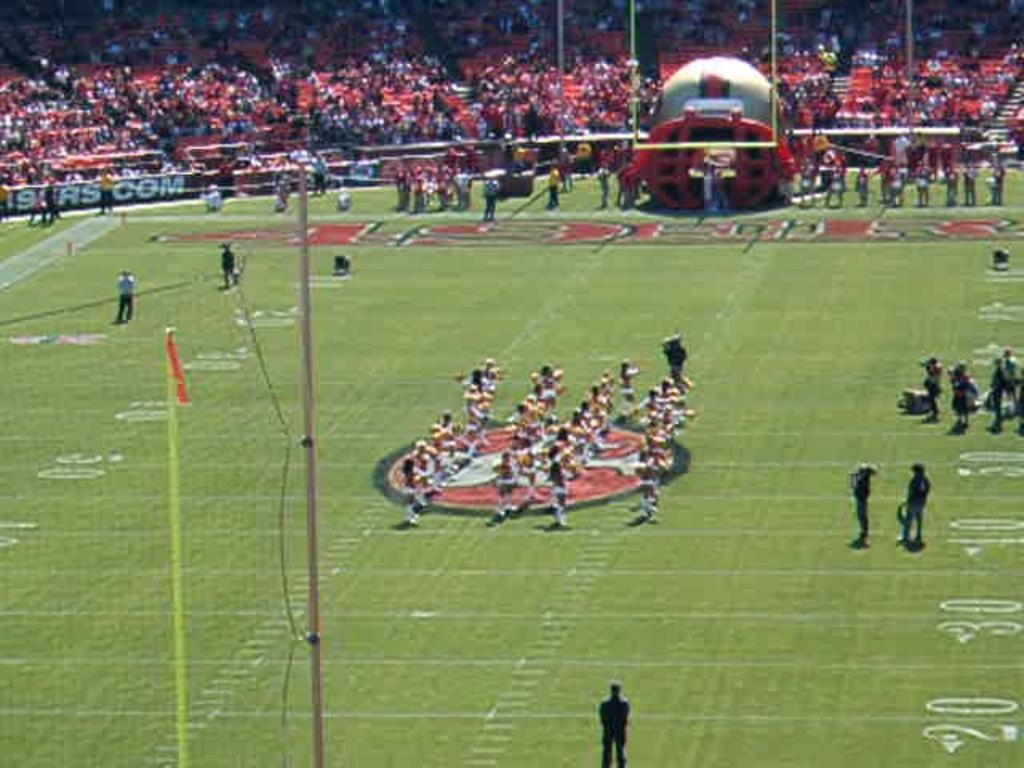Could you give a brief overview of what you see in this image? In the picture we can see a playground with green color carpet and on it we can see some people in the sportswear and in the background, we can see some poles, wall with advertisements and behind it we can see an audience sitting in the chairs. 